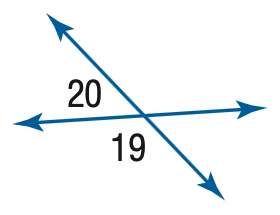Question: m \angle 19 = 100 + 20 x, m \angle 20 = 20 x. Find the measure of \angle 20.
Choices:
A. 20
B. 40
C. 60
D. 80
Answer with the letter. Answer: B 